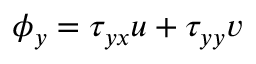Convert formula to latex. <formula><loc_0><loc_0><loc_500><loc_500>\phi _ { y } = \tau _ { y x } u + \tau _ { y y } v</formula> 